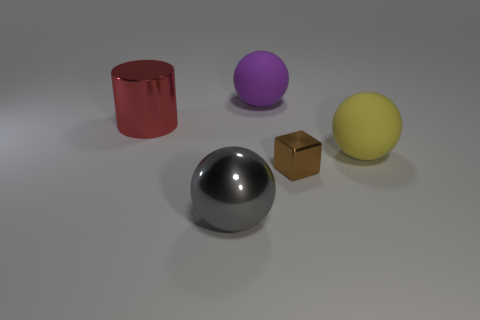Are there any other things that are the same shape as the brown object?
Your response must be concise. No. Is there anything else that is the same size as the brown metal cube?
Your answer should be very brief. No. How many large cylinders have the same color as the cube?
Your response must be concise. 0. What number of objects are purple rubber things or rubber things that are in front of the big cylinder?
Make the answer very short. 2. There is a rubber object that is to the right of the large rubber sphere that is on the left side of the brown cube; what is its size?
Provide a short and direct response. Large. Are there the same number of large shiny cylinders that are behind the red metallic cylinder and big gray objects that are in front of the large gray metallic thing?
Your answer should be very brief. Yes. Is there a brown block in front of the large object that is left of the metal sphere?
Provide a succinct answer. Yes. What is the shape of the other gray object that is made of the same material as the small thing?
Offer a very short reply. Sphere. Are there any other things that are the same color as the metallic sphere?
Ensure brevity in your answer.  No. There is a large thing on the right side of the matte thing that is behind the big red shiny cylinder; what is it made of?
Keep it short and to the point. Rubber. 